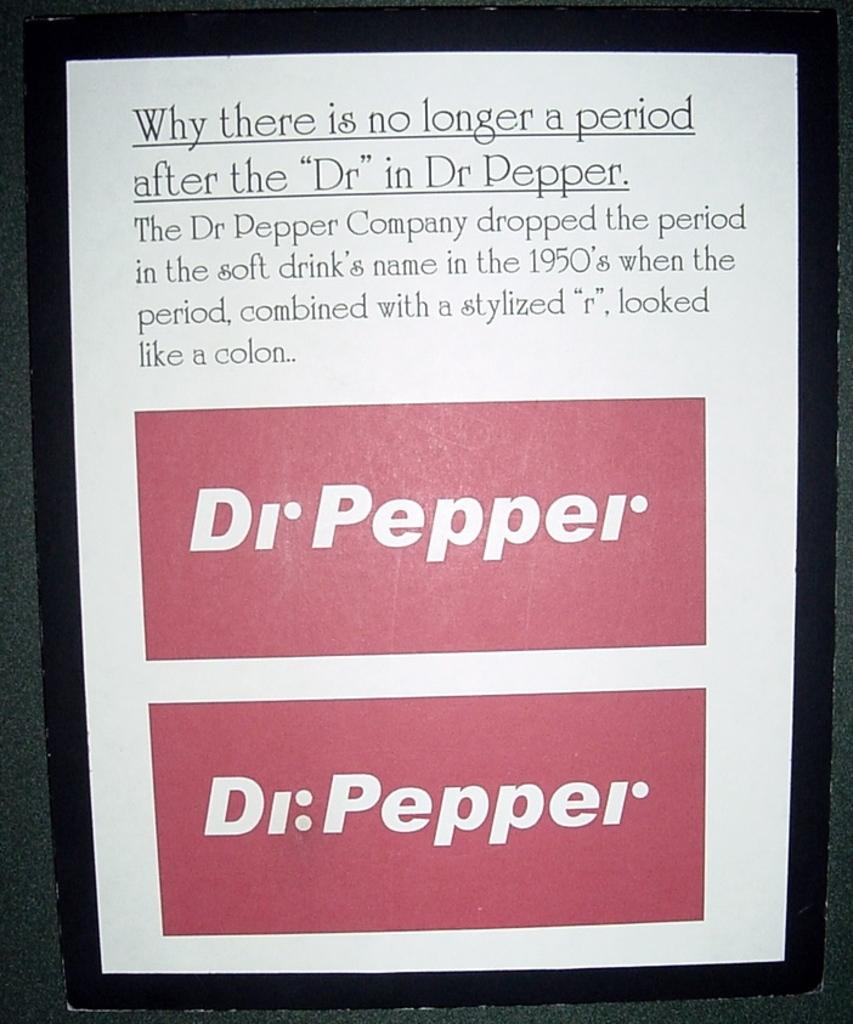<image>
Render a clear and concise summary of the photo. A poster explaining why there is no longer a period in Dr Pepper. 